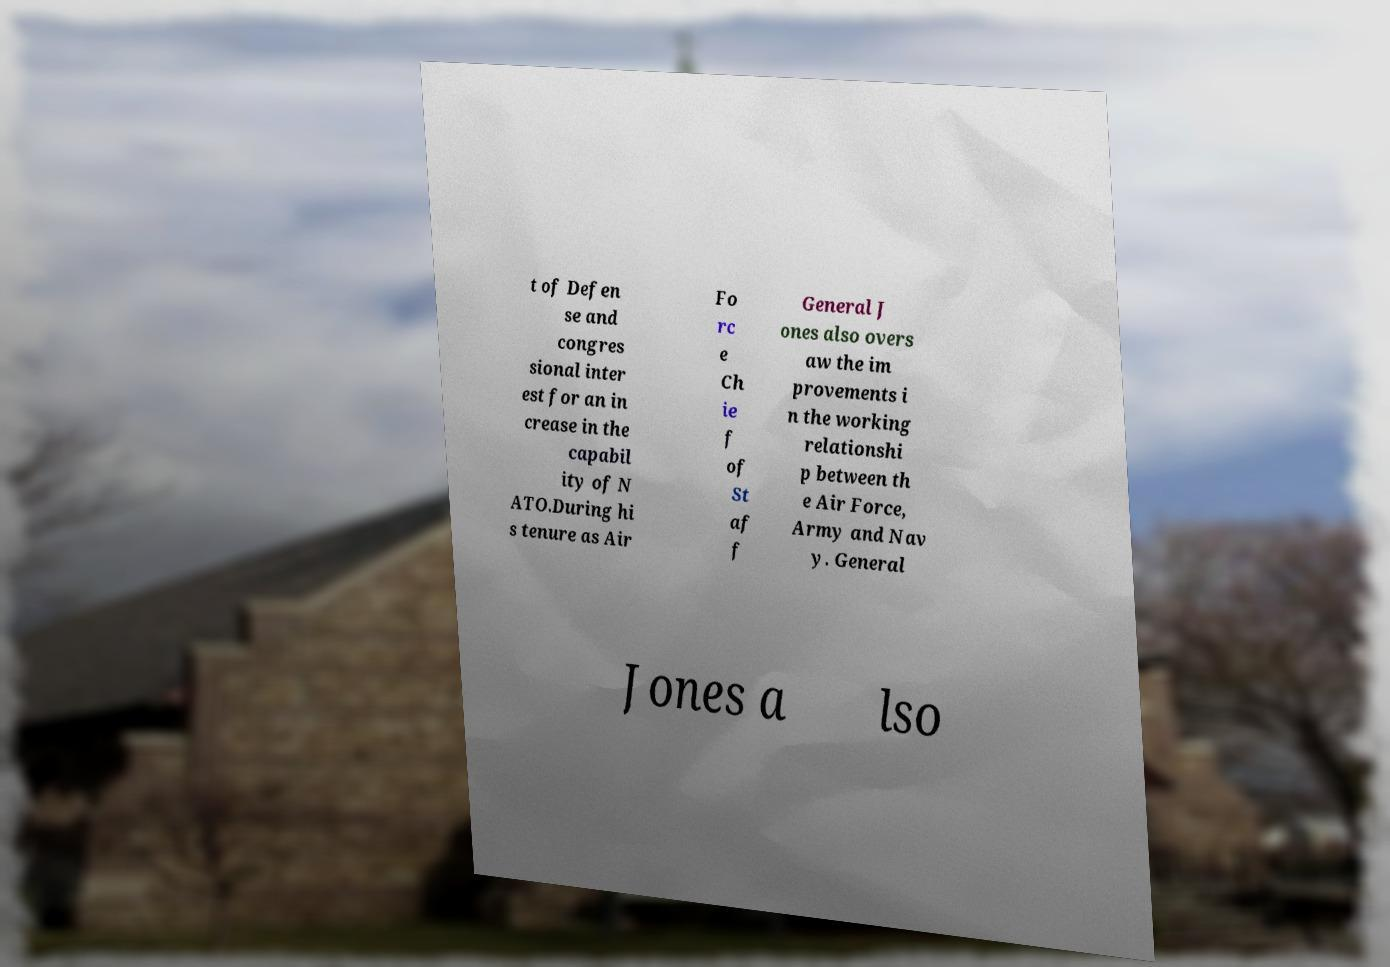Can you read and provide the text displayed in the image?This photo seems to have some interesting text. Can you extract and type it out for me? t of Defen se and congres sional inter est for an in crease in the capabil ity of N ATO.During hi s tenure as Air Fo rc e Ch ie f of St af f General J ones also overs aw the im provements i n the working relationshi p between th e Air Force, Army and Nav y. General Jones a lso 